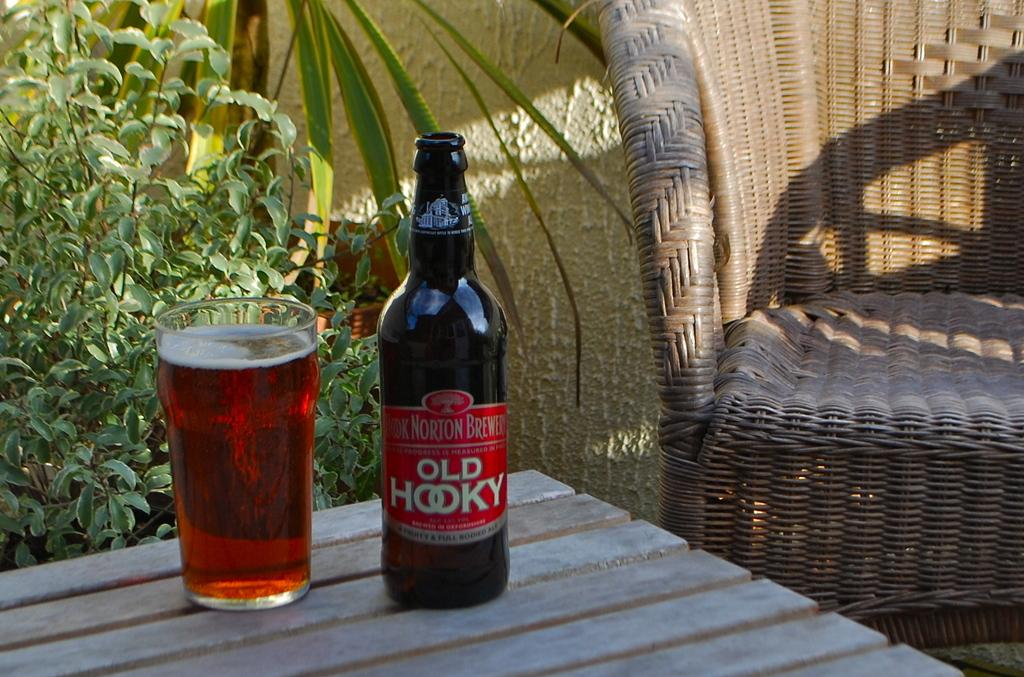<image>
Provide a brief description of the given image. Bottle with a red label that says Old Hooky next to a cup. 